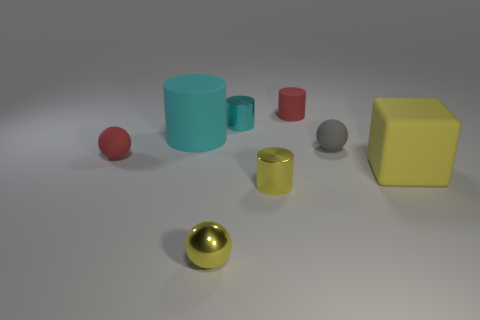There is a metal thing behind the rubber thing that is on the right side of the sphere on the right side of the cyan metal thing; what shape is it?
Ensure brevity in your answer.  Cylinder. Are there any other things that are made of the same material as the small gray ball?
Offer a terse response. Yes. There is another shiny thing that is the same shape as the gray object; what is its size?
Make the answer very short. Small. There is a tiny sphere that is both to the left of the tiny yellow cylinder and behind the large yellow rubber cube; what is its color?
Offer a very short reply. Red. Is the material of the yellow ball the same as the red thing behind the tiny gray rubber ball?
Your answer should be very brief. No. Is the number of cyan cylinders that are on the left side of the tiny cyan object less than the number of small cylinders?
Your response must be concise. Yes. What number of other things are the same shape as the large yellow object?
Give a very brief answer. 0. Are there any other things that are the same color as the large matte block?
Your answer should be compact. Yes. There is a large cylinder; is its color the same as the small rubber object behind the large cyan matte thing?
Your response must be concise. No. How many other things are the same size as the cyan metal cylinder?
Keep it short and to the point. 5. 